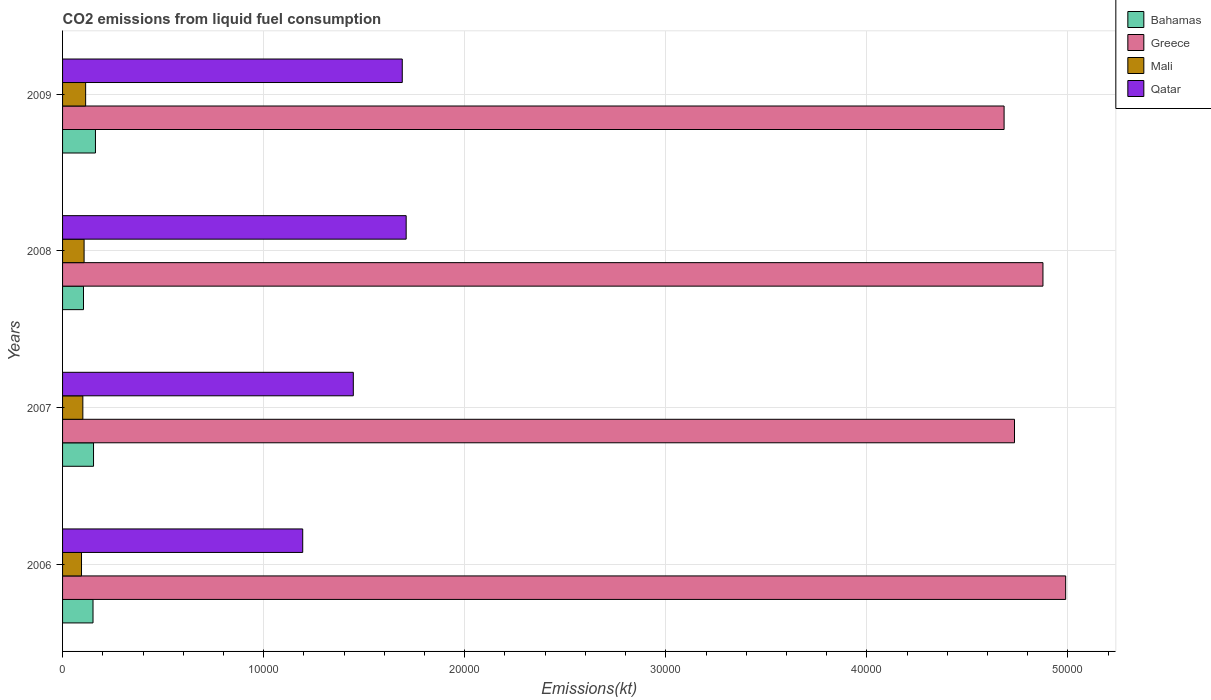How many different coloured bars are there?
Give a very brief answer. 4. Are the number of bars per tick equal to the number of legend labels?
Provide a succinct answer. Yes. Are the number of bars on each tick of the Y-axis equal?
Your answer should be compact. Yes. How many bars are there on the 1st tick from the top?
Provide a short and direct response. 4. In how many cases, is the number of bars for a given year not equal to the number of legend labels?
Ensure brevity in your answer.  0. What is the amount of CO2 emitted in Bahamas in 2007?
Your response must be concise. 1540.14. Across all years, what is the maximum amount of CO2 emitted in Bahamas?
Your answer should be very brief. 1635.48. Across all years, what is the minimum amount of CO2 emitted in Mali?
Give a very brief answer. 942.42. In which year was the amount of CO2 emitted in Bahamas maximum?
Ensure brevity in your answer.  2009. In which year was the amount of CO2 emitted in Bahamas minimum?
Offer a terse response. 2008. What is the total amount of CO2 emitted in Qatar in the graph?
Provide a succinct answer. 6.04e+04. What is the difference between the amount of CO2 emitted in Bahamas in 2006 and that in 2007?
Offer a terse response. -25.67. What is the difference between the amount of CO2 emitted in Qatar in 2009 and the amount of CO2 emitted in Greece in 2007?
Make the answer very short. -3.04e+04. What is the average amount of CO2 emitted in Bahamas per year?
Give a very brief answer. 1432.88. In the year 2006, what is the difference between the amount of CO2 emitted in Qatar and amount of CO2 emitted in Bahamas?
Your answer should be compact. 1.04e+04. In how many years, is the amount of CO2 emitted in Greece greater than 4000 kt?
Make the answer very short. 4. What is the ratio of the amount of CO2 emitted in Mali in 2008 to that in 2009?
Offer a very short reply. 0.93. Is the amount of CO2 emitted in Qatar in 2008 less than that in 2009?
Make the answer very short. No. Is the difference between the amount of CO2 emitted in Qatar in 2006 and 2007 greater than the difference between the amount of CO2 emitted in Bahamas in 2006 and 2007?
Ensure brevity in your answer.  No. What is the difference between the highest and the second highest amount of CO2 emitted in Bahamas?
Offer a very short reply. 95.34. What is the difference between the highest and the lowest amount of CO2 emitted in Bahamas?
Offer a terse response. 594.05. In how many years, is the amount of CO2 emitted in Bahamas greater than the average amount of CO2 emitted in Bahamas taken over all years?
Make the answer very short. 3. What does the 2nd bar from the top in 2009 represents?
Ensure brevity in your answer.  Mali. What does the 2nd bar from the bottom in 2006 represents?
Your answer should be compact. Greece. Is it the case that in every year, the sum of the amount of CO2 emitted in Bahamas and amount of CO2 emitted in Greece is greater than the amount of CO2 emitted in Mali?
Your response must be concise. Yes. How many bars are there?
Offer a very short reply. 16. Are all the bars in the graph horizontal?
Offer a terse response. Yes. What is the difference between two consecutive major ticks on the X-axis?
Offer a very short reply. 10000. Does the graph contain grids?
Keep it short and to the point. Yes. How many legend labels are there?
Offer a very short reply. 4. How are the legend labels stacked?
Your answer should be compact. Vertical. What is the title of the graph?
Provide a short and direct response. CO2 emissions from liquid fuel consumption. What is the label or title of the X-axis?
Your response must be concise. Emissions(kt). What is the label or title of the Y-axis?
Offer a terse response. Years. What is the Emissions(kt) in Bahamas in 2006?
Provide a succinct answer. 1514.47. What is the Emissions(kt) in Greece in 2006?
Your response must be concise. 4.99e+04. What is the Emissions(kt) in Mali in 2006?
Provide a succinct answer. 942.42. What is the Emissions(kt) in Qatar in 2006?
Ensure brevity in your answer.  1.19e+04. What is the Emissions(kt) in Bahamas in 2007?
Provide a succinct answer. 1540.14. What is the Emissions(kt) of Greece in 2007?
Your answer should be very brief. 4.73e+04. What is the Emissions(kt) in Mali in 2007?
Offer a very short reply. 1008.42. What is the Emissions(kt) in Qatar in 2007?
Your answer should be very brief. 1.45e+04. What is the Emissions(kt) in Bahamas in 2008?
Your response must be concise. 1041.43. What is the Emissions(kt) of Greece in 2008?
Your answer should be compact. 4.88e+04. What is the Emissions(kt) in Mali in 2008?
Your answer should be very brief. 1070.76. What is the Emissions(kt) in Qatar in 2008?
Make the answer very short. 1.71e+04. What is the Emissions(kt) of Bahamas in 2009?
Give a very brief answer. 1635.48. What is the Emissions(kt) of Greece in 2009?
Ensure brevity in your answer.  4.68e+04. What is the Emissions(kt) of Mali in 2009?
Your answer should be compact. 1147.77. What is the Emissions(kt) of Qatar in 2009?
Ensure brevity in your answer.  1.69e+04. Across all years, what is the maximum Emissions(kt) in Bahamas?
Offer a very short reply. 1635.48. Across all years, what is the maximum Emissions(kt) in Greece?
Keep it short and to the point. 4.99e+04. Across all years, what is the maximum Emissions(kt) in Mali?
Ensure brevity in your answer.  1147.77. Across all years, what is the maximum Emissions(kt) of Qatar?
Provide a succinct answer. 1.71e+04. Across all years, what is the minimum Emissions(kt) of Bahamas?
Your answer should be very brief. 1041.43. Across all years, what is the minimum Emissions(kt) in Greece?
Keep it short and to the point. 4.68e+04. Across all years, what is the minimum Emissions(kt) in Mali?
Your answer should be very brief. 942.42. Across all years, what is the minimum Emissions(kt) of Qatar?
Give a very brief answer. 1.19e+04. What is the total Emissions(kt) of Bahamas in the graph?
Your response must be concise. 5731.52. What is the total Emissions(kt) of Greece in the graph?
Your response must be concise. 1.93e+05. What is the total Emissions(kt) of Mali in the graph?
Give a very brief answer. 4169.38. What is the total Emissions(kt) in Qatar in the graph?
Provide a succinct answer. 6.04e+04. What is the difference between the Emissions(kt) of Bahamas in 2006 and that in 2007?
Provide a succinct answer. -25.67. What is the difference between the Emissions(kt) in Greece in 2006 and that in 2007?
Offer a very short reply. 2544.9. What is the difference between the Emissions(kt) in Mali in 2006 and that in 2007?
Your answer should be compact. -66.01. What is the difference between the Emissions(kt) of Qatar in 2006 and that in 2007?
Provide a short and direct response. -2515.56. What is the difference between the Emissions(kt) in Bahamas in 2006 and that in 2008?
Give a very brief answer. 473.04. What is the difference between the Emissions(kt) of Greece in 2006 and that in 2008?
Provide a succinct answer. 1129.44. What is the difference between the Emissions(kt) in Mali in 2006 and that in 2008?
Your answer should be very brief. -128.34. What is the difference between the Emissions(kt) in Qatar in 2006 and that in 2008?
Make the answer very short. -5144.8. What is the difference between the Emissions(kt) in Bahamas in 2006 and that in 2009?
Ensure brevity in your answer.  -121.01. What is the difference between the Emissions(kt) in Greece in 2006 and that in 2009?
Your answer should be very brief. 3061.95. What is the difference between the Emissions(kt) in Mali in 2006 and that in 2009?
Your response must be concise. -205.35. What is the difference between the Emissions(kt) of Qatar in 2006 and that in 2009?
Keep it short and to the point. -4950.45. What is the difference between the Emissions(kt) in Bahamas in 2007 and that in 2008?
Your answer should be very brief. 498.71. What is the difference between the Emissions(kt) in Greece in 2007 and that in 2008?
Give a very brief answer. -1415.46. What is the difference between the Emissions(kt) of Mali in 2007 and that in 2008?
Keep it short and to the point. -62.34. What is the difference between the Emissions(kt) in Qatar in 2007 and that in 2008?
Offer a very short reply. -2629.24. What is the difference between the Emissions(kt) of Bahamas in 2007 and that in 2009?
Your answer should be very brief. -95.34. What is the difference between the Emissions(kt) of Greece in 2007 and that in 2009?
Make the answer very short. 517.05. What is the difference between the Emissions(kt) of Mali in 2007 and that in 2009?
Your response must be concise. -139.35. What is the difference between the Emissions(kt) in Qatar in 2007 and that in 2009?
Your answer should be very brief. -2434.89. What is the difference between the Emissions(kt) in Bahamas in 2008 and that in 2009?
Your answer should be very brief. -594.05. What is the difference between the Emissions(kt) in Greece in 2008 and that in 2009?
Provide a short and direct response. 1932.51. What is the difference between the Emissions(kt) in Mali in 2008 and that in 2009?
Keep it short and to the point. -77.01. What is the difference between the Emissions(kt) of Qatar in 2008 and that in 2009?
Your answer should be compact. 194.35. What is the difference between the Emissions(kt) of Bahamas in 2006 and the Emissions(kt) of Greece in 2007?
Your response must be concise. -4.58e+04. What is the difference between the Emissions(kt) in Bahamas in 2006 and the Emissions(kt) in Mali in 2007?
Your response must be concise. 506.05. What is the difference between the Emissions(kt) in Bahamas in 2006 and the Emissions(kt) in Qatar in 2007?
Ensure brevity in your answer.  -1.29e+04. What is the difference between the Emissions(kt) of Greece in 2006 and the Emissions(kt) of Mali in 2007?
Keep it short and to the point. 4.89e+04. What is the difference between the Emissions(kt) in Greece in 2006 and the Emissions(kt) in Qatar in 2007?
Offer a terse response. 3.54e+04. What is the difference between the Emissions(kt) of Mali in 2006 and the Emissions(kt) of Qatar in 2007?
Offer a terse response. -1.35e+04. What is the difference between the Emissions(kt) of Bahamas in 2006 and the Emissions(kt) of Greece in 2008?
Make the answer very short. -4.72e+04. What is the difference between the Emissions(kt) in Bahamas in 2006 and the Emissions(kt) in Mali in 2008?
Provide a succinct answer. 443.71. What is the difference between the Emissions(kt) of Bahamas in 2006 and the Emissions(kt) of Qatar in 2008?
Your answer should be very brief. -1.56e+04. What is the difference between the Emissions(kt) in Greece in 2006 and the Emissions(kt) in Mali in 2008?
Your response must be concise. 4.88e+04. What is the difference between the Emissions(kt) of Greece in 2006 and the Emissions(kt) of Qatar in 2008?
Your answer should be compact. 3.28e+04. What is the difference between the Emissions(kt) in Mali in 2006 and the Emissions(kt) in Qatar in 2008?
Make the answer very short. -1.61e+04. What is the difference between the Emissions(kt) in Bahamas in 2006 and the Emissions(kt) in Greece in 2009?
Offer a very short reply. -4.53e+04. What is the difference between the Emissions(kt) of Bahamas in 2006 and the Emissions(kt) of Mali in 2009?
Ensure brevity in your answer.  366.7. What is the difference between the Emissions(kt) of Bahamas in 2006 and the Emissions(kt) of Qatar in 2009?
Keep it short and to the point. -1.54e+04. What is the difference between the Emissions(kt) of Greece in 2006 and the Emissions(kt) of Mali in 2009?
Give a very brief answer. 4.87e+04. What is the difference between the Emissions(kt) in Greece in 2006 and the Emissions(kt) in Qatar in 2009?
Your response must be concise. 3.30e+04. What is the difference between the Emissions(kt) in Mali in 2006 and the Emissions(kt) in Qatar in 2009?
Your response must be concise. -1.60e+04. What is the difference between the Emissions(kt) of Bahamas in 2007 and the Emissions(kt) of Greece in 2008?
Your answer should be very brief. -4.72e+04. What is the difference between the Emissions(kt) of Bahamas in 2007 and the Emissions(kt) of Mali in 2008?
Your answer should be compact. 469.38. What is the difference between the Emissions(kt) in Bahamas in 2007 and the Emissions(kt) in Qatar in 2008?
Offer a terse response. -1.55e+04. What is the difference between the Emissions(kt) in Greece in 2007 and the Emissions(kt) in Mali in 2008?
Provide a short and direct response. 4.63e+04. What is the difference between the Emissions(kt) of Greece in 2007 and the Emissions(kt) of Qatar in 2008?
Give a very brief answer. 3.03e+04. What is the difference between the Emissions(kt) of Mali in 2007 and the Emissions(kt) of Qatar in 2008?
Make the answer very short. -1.61e+04. What is the difference between the Emissions(kt) in Bahamas in 2007 and the Emissions(kt) in Greece in 2009?
Provide a succinct answer. -4.53e+04. What is the difference between the Emissions(kt) in Bahamas in 2007 and the Emissions(kt) in Mali in 2009?
Offer a terse response. 392.37. What is the difference between the Emissions(kt) of Bahamas in 2007 and the Emissions(kt) of Qatar in 2009?
Provide a succinct answer. -1.54e+04. What is the difference between the Emissions(kt) in Greece in 2007 and the Emissions(kt) in Mali in 2009?
Ensure brevity in your answer.  4.62e+04. What is the difference between the Emissions(kt) of Greece in 2007 and the Emissions(kt) of Qatar in 2009?
Ensure brevity in your answer.  3.04e+04. What is the difference between the Emissions(kt) of Mali in 2007 and the Emissions(kt) of Qatar in 2009?
Your response must be concise. -1.59e+04. What is the difference between the Emissions(kt) in Bahamas in 2008 and the Emissions(kt) in Greece in 2009?
Make the answer very short. -4.58e+04. What is the difference between the Emissions(kt) in Bahamas in 2008 and the Emissions(kt) in Mali in 2009?
Make the answer very short. -106.34. What is the difference between the Emissions(kt) in Bahamas in 2008 and the Emissions(kt) in Qatar in 2009?
Make the answer very short. -1.59e+04. What is the difference between the Emissions(kt) in Greece in 2008 and the Emissions(kt) in Mali in 2009?
Offer a very short reply. 4.76e+04. What is the difference between the Emissions(kt) in Greece in 2008 and the Emissions(kt) in Qatar in 2009?
Give a very brief answer. 3.19e+04. What is the difference between the Emissions(kt) of Mali in 2008 and the Emissions(kt) of Qatar in 2009?
Your response must be concise. -1.58e+04. What is the average Emissions(kt) in Bahamas per year?
Your answer should be very brief. 1432.88. What is the average Emissions(kt) in Greece per year?
Provide a short and direct response. 4.82e+04. What is the average Emissions(kt) of Mali per year?
Ensure brevity in your answer.  1042.34. What is the average Emissions(kt) of Qatar per year?
Provide a short and direct response. 1.51e+04. In the year 2006, what is the difference between the Emissions(kt) of Bahamas and Emissions(kt) of Greece?
Give a very brief answer. -4.84e+04. In the year 2006, what is the difference between the Emissions(kt) of Bahamas and Emissions(kt) of Mali?
Offer a terse response. 572.05. In the year 2006, what is the difference between the Emissions(kt) of Bahamas and Emissions(kt) of Qatar?
Ensure brevity in your answer.  -1.04e+04. In the year 2006, what is the difference between the Emissions(kt) in Greece and Emissions(kt) in Mali?
Give a very brief answer. 4.89e+04. In the year 2006, what is the difference between the Emissions(kt) in Greece and Emissions(kt) in Qatar?
Your answer should be compact. 3.79e+04. In the year 2006, what is the difference between the Emissions(kt) of Mali and Emissions(kt) of Qatar?
Provide a short and direct response. -1.10e+04. In the year 2007, what is the difference between the Emissions(kt) in Bahamas and Emissions(kt) in Greece?
Your answer should be compact. -4.58e+04. In the year 2007, what is the difference between the Emissions(kt) in Bahamas and Emissions(kt) in Mali?
Offer a very short reply. 531.72. In the year 2007, what is the difference between the Emissions(kt) in Bahamas and Emissions(kt) in Qatar?
Your answer should be compact. -1.29e+04. In the year 2007, what is the difference between the Emissions(kt) of Greece and Emissions(kt) of Mali?
Your answer should be very brief. 4.63e+04. In the year 2007, what is the difference between the Emissions(kt) in Greece and Emissions(kt) in Qatar?
Provide a succinct answer. 3.29e+04. In the year 2007, what is the difference between the Emissions(kt) of Mali and Emissions(kt) of Qatar?
Provide a short and direct response. -1.35e+04. In the year 2008, what is the difference between the Emissions(kt) in Bahamas and Emissions(kt) in Greece?
Your response must be concise. -4.77e+04. In the year 2008, what is the difference between the Emissions(kt) of Bahamas and Emissions(kt) of Mali?
Ensure brevity in your answer.  -29.34. In the year 2008, what is the difference between the Emissions(kt) in Bahamas and Emissions(kt) in Qatar?
Provide a short and direct response. -1.60e+04. In the year 2008, what is the difference between the Emissions(kt) of Greece and Emissions(kt) of Mali?
Your answer should be compact. 4.77e+04. In the year 2008, what is the difference between the Emissions(kt) in Greece and Emissions(kt) in Qatar?
Your response must be concise. 3.17e+04. In the year 2008, what is the difference between the Emissions(kt) of Mali and Emissions(kt) of Qatar?
Provide a succinct answer. -1.60e+04. In the year 2009, what is the difference between the Emissions(kt) of Bahamas and Emissions(kt) of Greece?
Make the answer very short. -4.52e+04. In the year 2009, what is the difference between the Emissions(kt) in Bahamas and Emissions(kt) in Mali?
Give a very brief answer. 487.71. In the year 2009, what is the difference between the Emissions(kt) in Bahamas and Emissions(kt) in Qatar?
Make the answer very short. -1.53e+04. In the year 2009, what is the difference between the Emissions(kt) in Greece and Emissions(kt) in Mali?
Provide a succinct answer. 4.57e+04. In the year 2009, what is the difference between the Emissions(kt) in Greece and Emissions(kt) in Qatar?
Give a very brief answer. 2.99e+04. In the year 2009, what is the difference between the Emissions(kt) in Mali and Emissions(kt) in Qatar?
Keep it short and to the point. -1.57e+04. What is the ratio of the Emissions(kt) in Bahamas in 2006 to that in 2007?
Your response must be concise. 0.98. What is the ratio of the Emissions(kt) of Greece in 2006 to that in 2007?
Provide a short and direct response. 1.05. What is the ratio of the Emissions(kt) of Mali in 2006 to that in 2007?
Your answer should be very brief. 0.93. What is the ratio of the Emissions(kt) of Qatar in 2006 to that in 2007?
Give a very brief answer. 0.83. What is the ratio of the Emissions(kt) of Bahamas in 2006 to that in 2008?
Your answer should be very brief. 1.45. What is the ratio of the Emissions(kt) of Greece in 2006 to that in 2008?
Your answer should be very brief. 1.02. What is the ratio of the Emissions(kt) in Mali in 2006 to that in 2008?
Keep it short and to the point. 0.88. What is the ratio of the Emissions(kt) in Qatar in 2006 to that in 2008?
Ensure brevity in your answer.  0.7. What is the ratio of the Emissions(kt) of Bahamas in 2006 to that in 2009?
Provide a short and direct response. 0.93. What is the ratio of the Emissions(kt) in Greece in 2006 to that in 2009?
Offer a very short reply. 1.07. What is the ratio of the Emissions(kt) of Mali in 2006 to that in 2009?
Offer a very short reply. 0.82. What is the ratio of the Emissions(kt) of Qatar in 2006 to that in 2009?
Your answer should be compact. 0.71. What is the ratio of the Emissions(kt) in Bahamas in 2007 to that in 2008?
Offer a very short reply. 1.48. What is the ratio of the Emissions(kt) of Greece in 2007 to that in 2008?
Your answer should be very brief. 0.97. What is the ratio of the Emissions(kt) in Mali in 2007 to that in 2008?
Your answer should be very brief. 0.94. What is the ratio of the Emissions(kt) in Qatar in 2007 to that in 2008?
Make the answer very short. 0.85. What is the ratio of the Emissions(kt) in Bahamas in 2007 to that in 2009?
Provide a succinct answer. 0.94. What is the ratio of the Emissions(kt) in Mali in 2007 to that in 2009?
Offer a very short reply. 0.88. What is the ratio of the Emissions(kt) of Qatar in 2007 to that in 2009?
Provide a succinct answer. 0.86. What is the ratio of the Emissions(kt) in Bahamas in 2008 to that in 2009?
Provide a short and direct response. 0.64. What is the ratio of the Emissions(kt) of Greece in 2008 to that in 2009?
Make the answer very short. 1.04. What is the ratio of the Emissions(kt) in Mali in 2008 to that in 2009?
Offer a terse response. 0.93. What is the ratio of the Emissions(kt) in Qatar in 2008 to that in 2009?
Offer a very short reply. 1.01. What is the difference between the highest and the second highest Emissions(kt) of Bahamas?
Provide a succinct answer. 95.34. What is the difference between the highest and the second highest Emissions(kt) of Greece?
Your response must be concise. 1129.44. What is the difference between the highest and the second highest Emissions(kt) in Mali?
Give a very brief answer. 77.01. What is the difference between the highest and the second highest Emissions(kt) of Qatar?
Provide a short and direct response. 194.35. What is the difference between the highest and the lowest Emissions(kt) of Bahamas?
Your answer should be very brief. 594.05. What is the difference between the highest and the lowest Emissions(kt) of Greece?
Keep it short and to the point. 3061.95. What is the difference between the highest and the lowest Emissions(kt) of Mali?
Your response must be concise. 205.35. What is the difference between the highest and the lowest Emissions(kt) of Qatar?
Keep it short and to the point. 5144.8. 